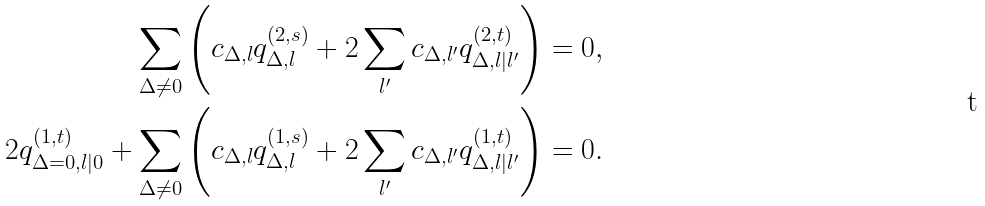<formula> <loc_0><loc_0><loc_500><loc_500>\sum _ { \Delta \neq 0 } \left ( c _ { \Delta , l } q _ { \Delta , l } ^ { ( 2 , s ) } + 2 \sum _ { l ^ { \prime } } c _ { \Delta , l ^ { \prime } } q ^ { ( 2 , t ) } _ { \Delta , l | l ^ { \prime } } \right ) & = 0 , \\ 2 q _ { \Delta = 0 , l | 0 } ^ { ( 1 , t ) } + \sum _ { \Delta \neq 0 } \left ( c _ { \Delta , l } q _ { \Delta , l } ^ { ( 1 , s ) } + 2 \sum _ { l ^ { \prime } } c _ { \Delta , l ^ { \prime } } q ^ { ( 1 , t ) } _ { \Delta , l | l ^ { \prime } } \right ) & = 0 .</formula> 